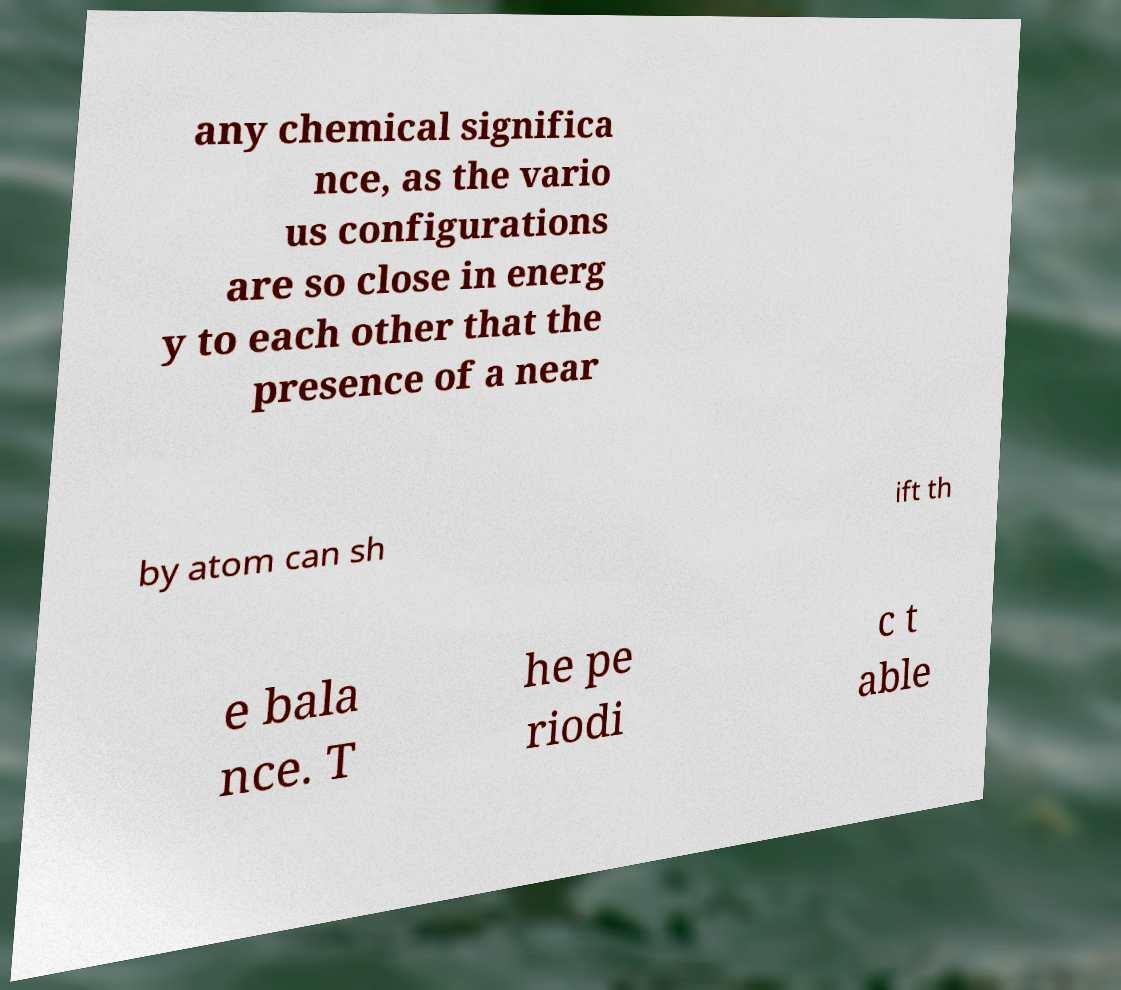Could you extract and type out the text from this image? any chemical significa nce, as the vario us configurations are so close in energ y to each other that the presence of a near by atom can sh ift th e bala nce. T he pe riodi c t able 